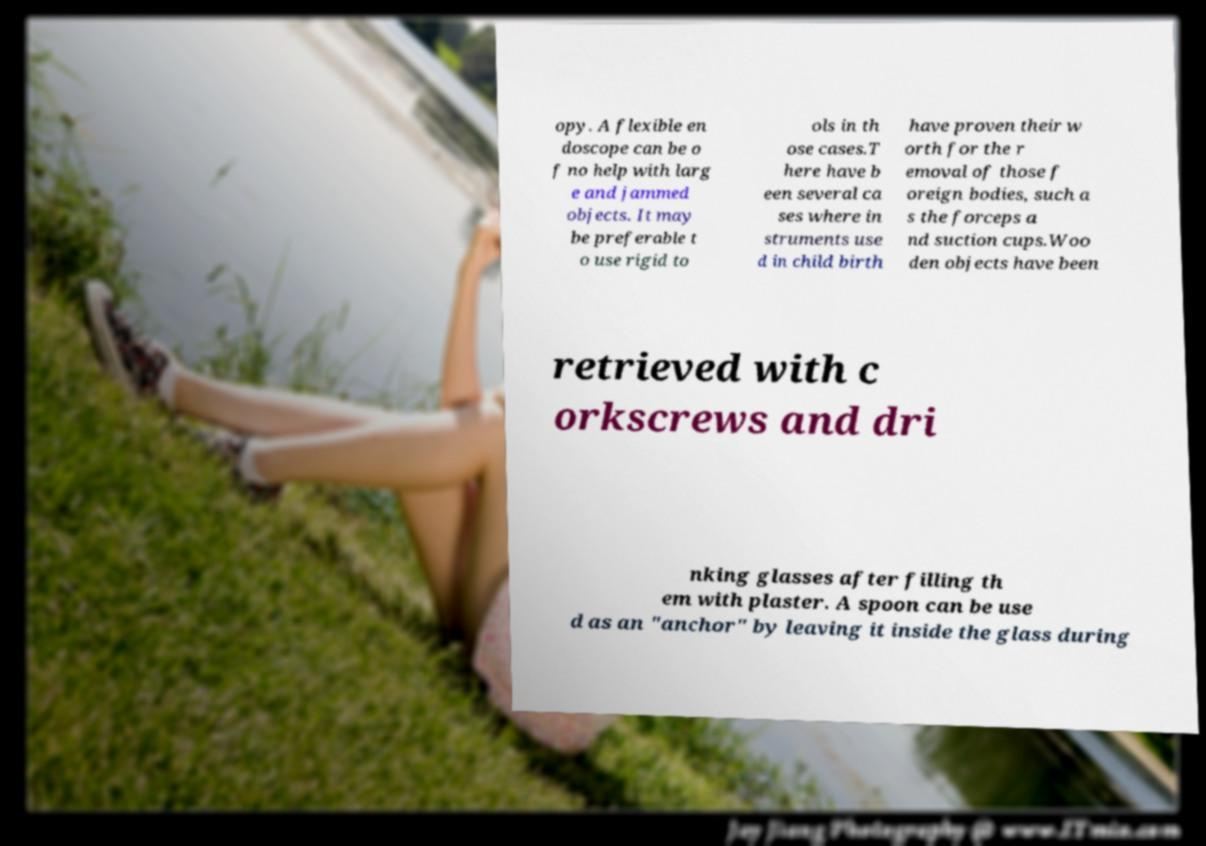Could you assist in decoding the text presented in this image and type it out clearly? opy. A flexible en doscope can be o f no help with larg e and jammed objects. It may be preferable t o use rigid to ols in th ose cases.T here have b een several ca ses where in struments use d in child birth have proven their w orth for the r emoval of those f oreign bodies, such a s the forceps a nd suction cups.Woo den objects have been retrieved with c orkscrews and dri nking glasses after filling th em with plaster. A spoon can be use d as an "anchor" by leaving it inside the glass during 